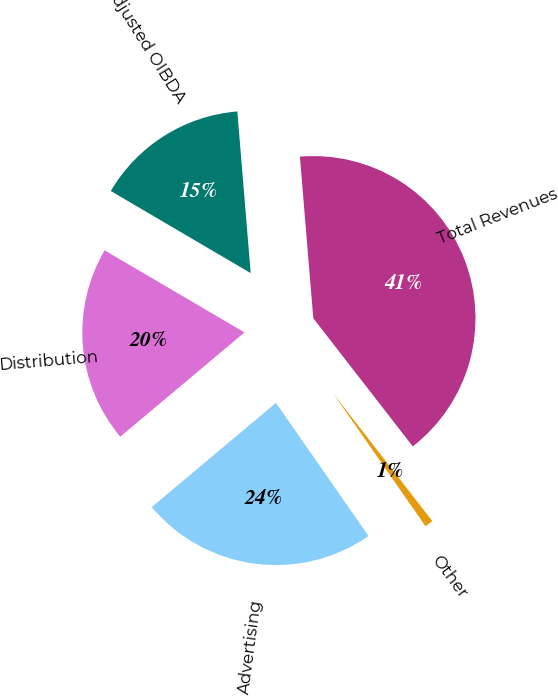Convert chart to OTSL. <chart><loc_0><loc_0><loc_500><loc_500><pie_chart><fcel>Distribution<fcel>Advertising<fcel>Other<fcel>Total Revenues<fcel>Adjusted OIBDA<nl><fcel>19.56%<fcel>23.56%<fcel>0.84%<fcel>40.81%<fcel>15.24%<nl></chart> 